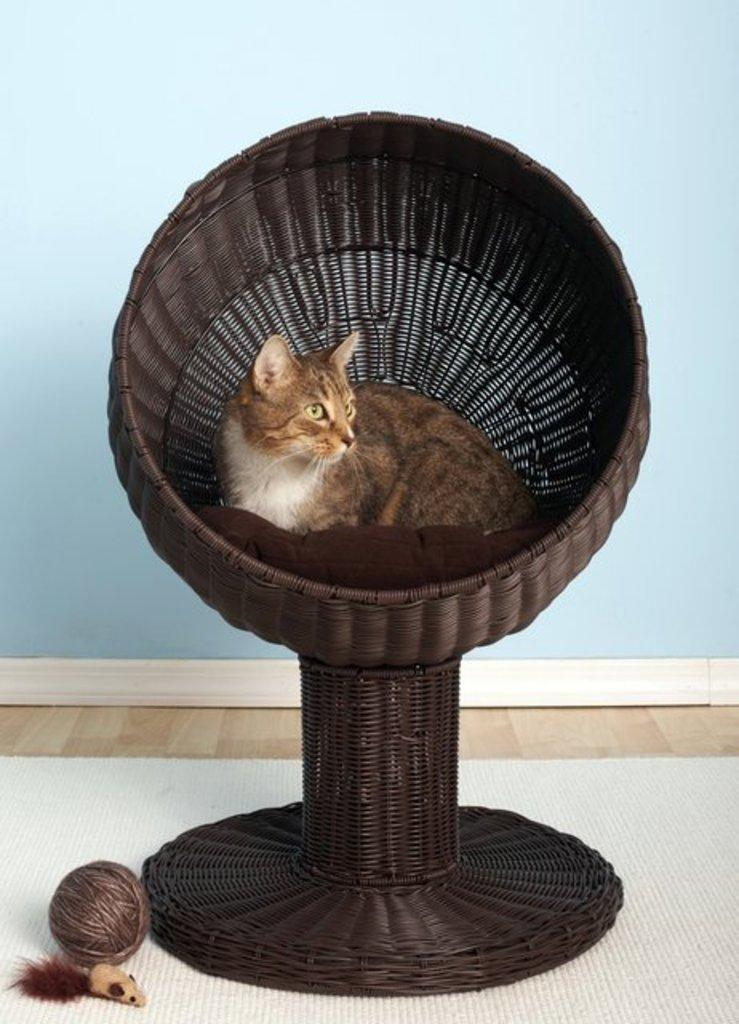What is the cat doing in the image? The cat is sitting in a basket. What is the color of the surface the basket is on? The surface is white color. What else can be seen on the white color surface? There is a thread bundle and a toy on the white color surface. What color is the wall in the background? The wall in the background is blue color. What shape is the yam on the blue color wall in the image? There is no yam present in the image, so we cannot determine its shape. 